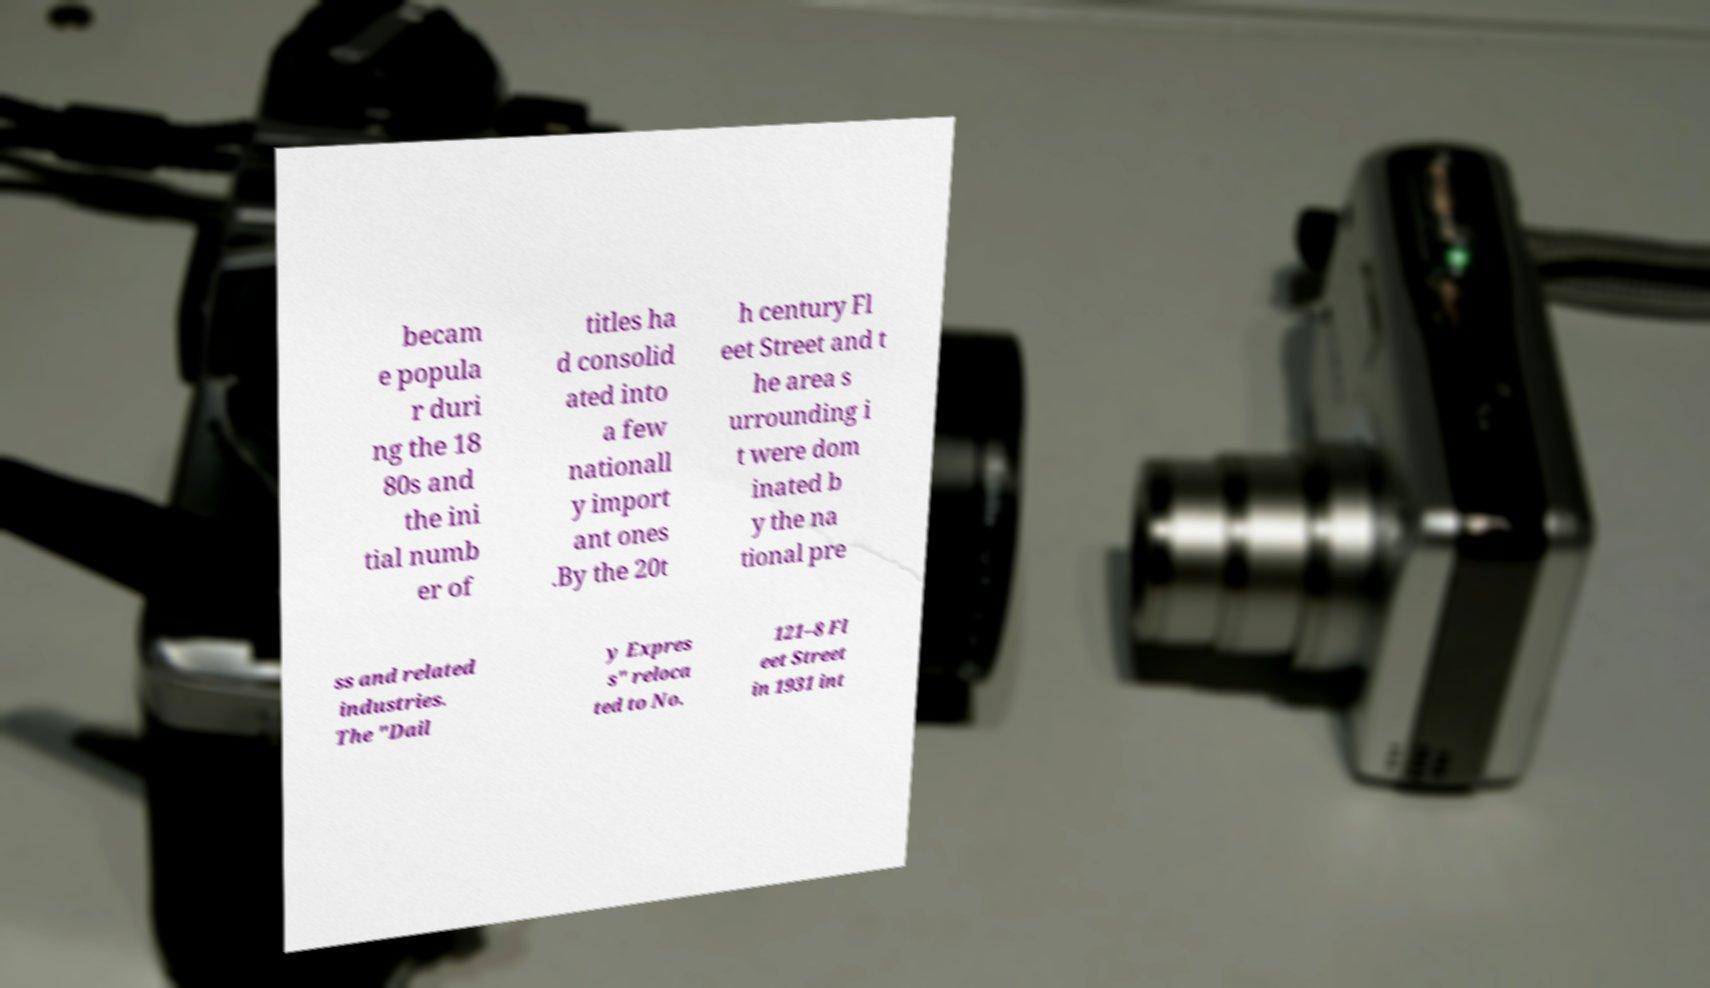There's text embedded in this image that I need extracted. Can you transcribe it verbatim? becam e popula r duri ng the 18 80s and the ini tial numb er of titles ha d consolid ated into a few nationall y import ant ones .By the 20t h century Fl eet Street and t he area s urrounding i t were dom inated b y the na tional pre ss and related industries. The "Dail y Expres s" reloca ted to No. 121–8 Fl eet Street in 1931 int 